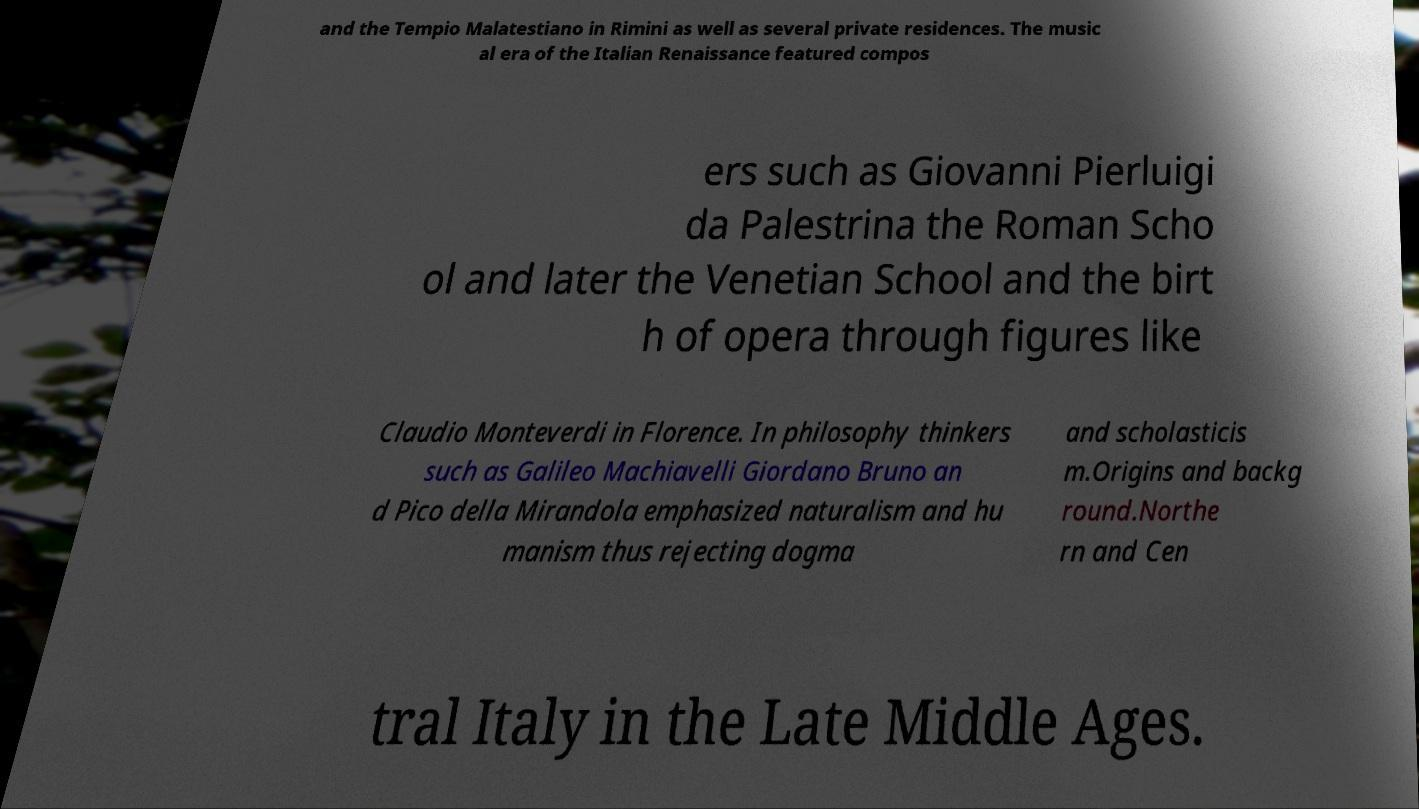Please identify and transcribe the text found in this image. and the Tempio Malatestiano in Rimini as well as several private residences. The music al era of the Italian Renaissance featured compos ers such as Giovanni Pierluigi da Palestrina the Roman Scho ol and later the Venetian School and the birt h of opera through figures like Claudio Monteverdi in Florence. In philosophy thinkers such as Galileo Machiavelli Giordano Bruno an d Pico della Mirandola emphasized naturalism and hu manism thus rejecting dogma and scholasticis m.Origins and backg round.Northe rn and Cen tral Italy in the Late Middle Ages. 